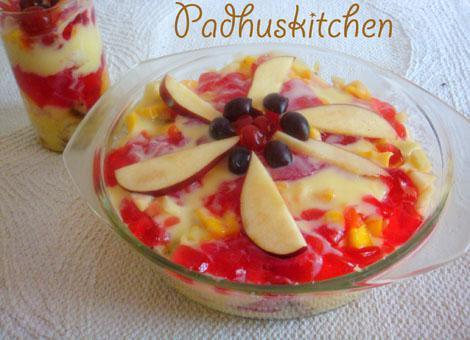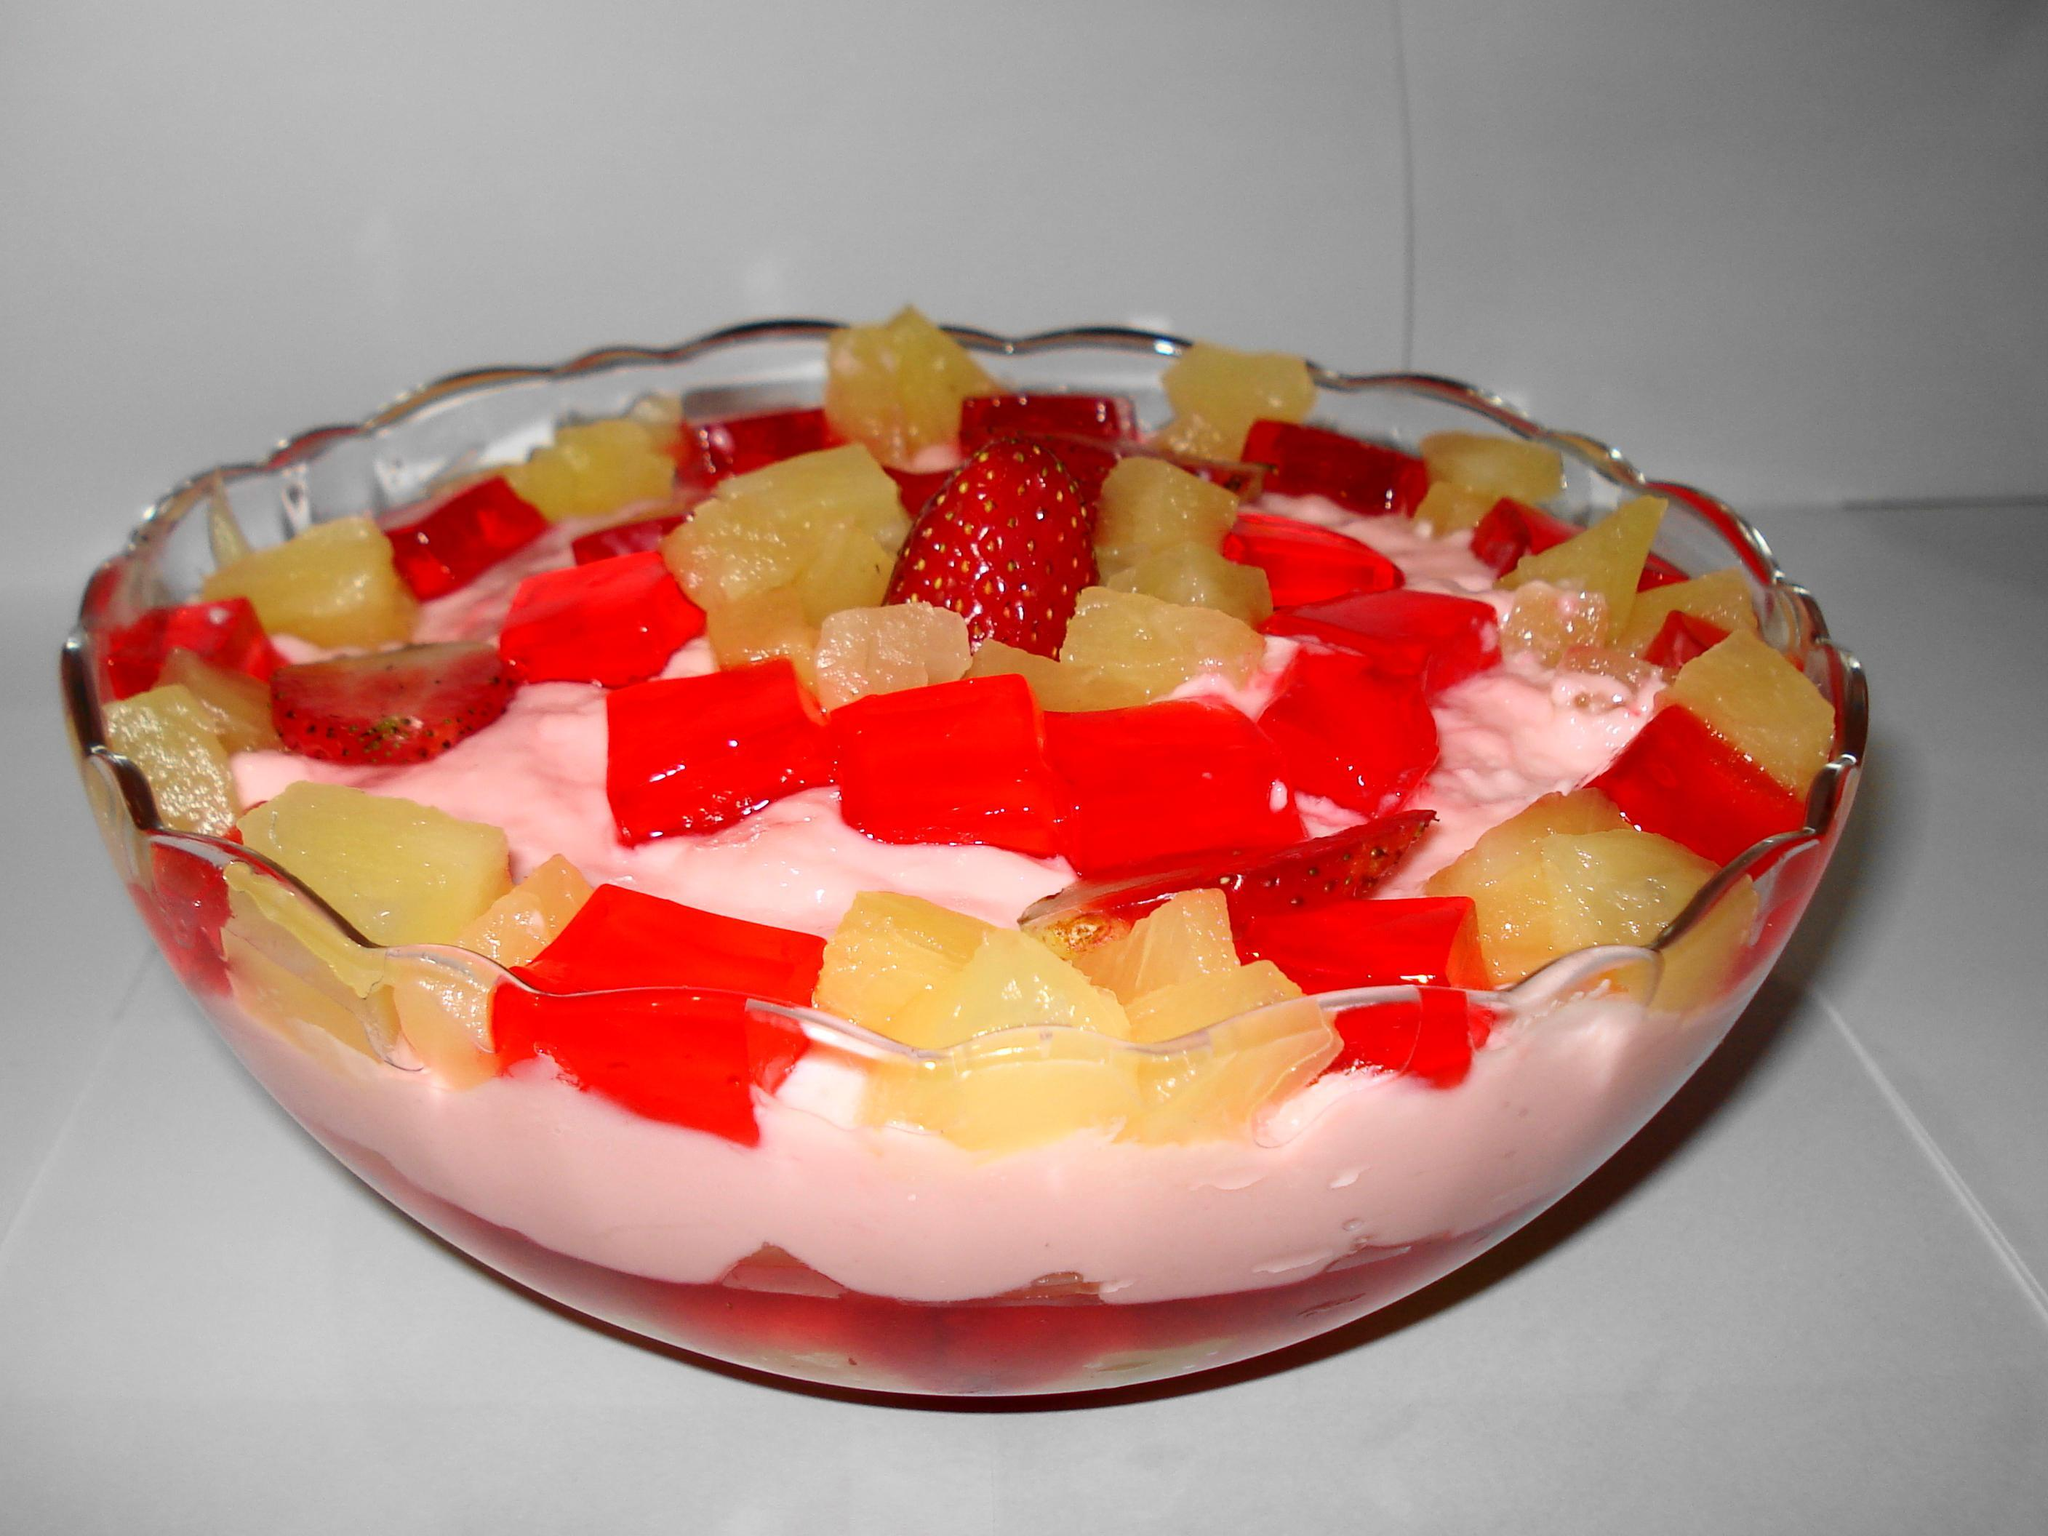The first image is the image on the left, the second image is the image on the right. Evaluate the accuracy of this statement regarding the images: "There are spoons resting next to a cup of trifle.". Is it true? Answer yes or no. No. 